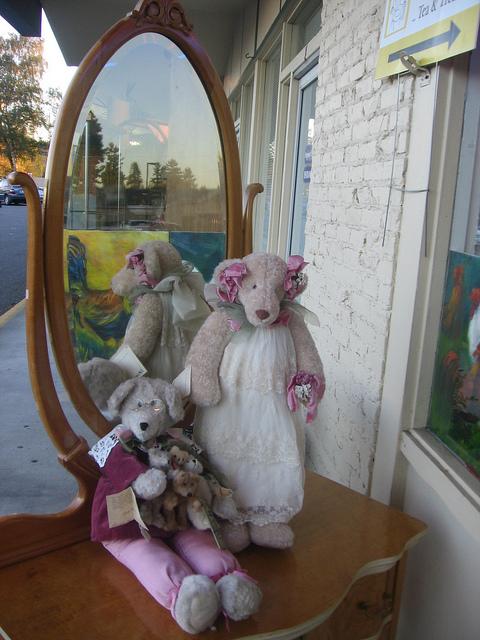Is there a mirror in this photo?
Answer briefly. Yes. Where are the bears sitting?
Short answer required. Dresser. How many stuffed animals are shown?
Concise answer only. 2. Which one is wearing a dress?
Concise answer only. Right. 